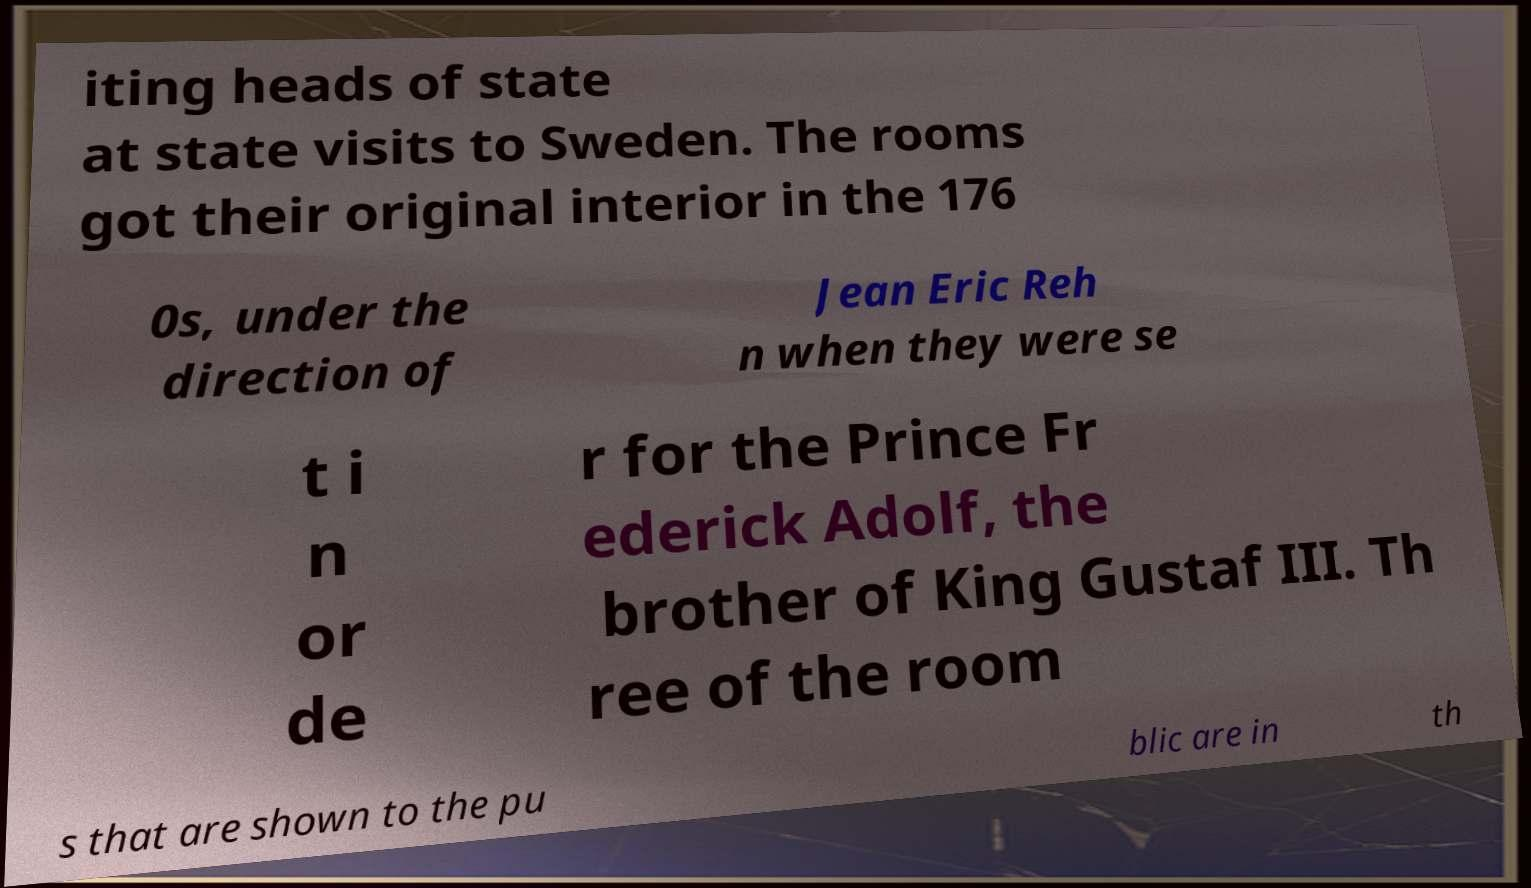Could you extract and type out the text from this image? iting heads of state at state visits to Sweden. The rooms got their original interior in the 176 0s, under the direction of Jean Eric Reh n when they were se t i n or de r for the Prince Fr ederick Adolf, the brother of King Gustaf III. Th ree of the room s that are shown to the pu blic are in th 